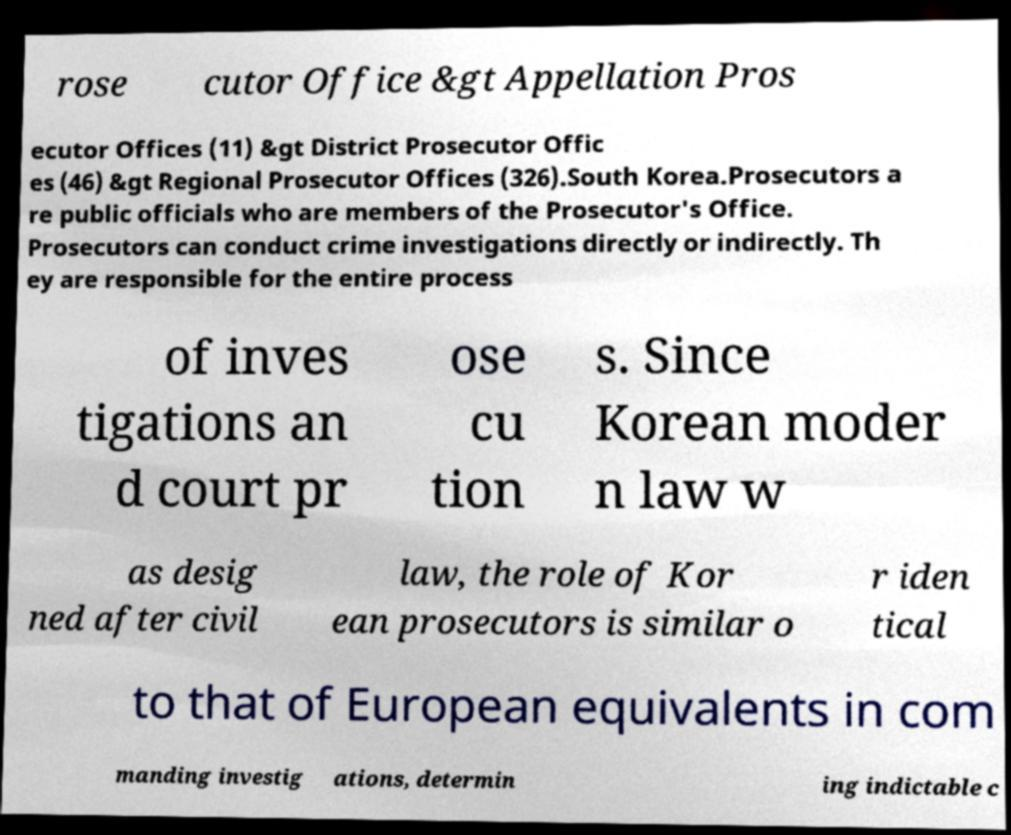Please read and relay the text visible in this image. What does it say? rose cutor Office &gt Appellation Pros ecutor Offices (11) &gt District Prosecutor Offic es (46) &gt Regional Prosecutor Offices (326).South Korea.Prosecutors a re public officials who are members of the Prosecutor's Office. Prosecutors can conduct crime investigations directly or indirectly. Th ey are responsible for the entire process of inves tigations an d court pr ose cu tion s. Since Korean moder n law w as desig ned after civil law, the role of Kor ean prosecutors is similar o r iden tical to that of European equivalents in com manding investig ations, determin ing indictable c 